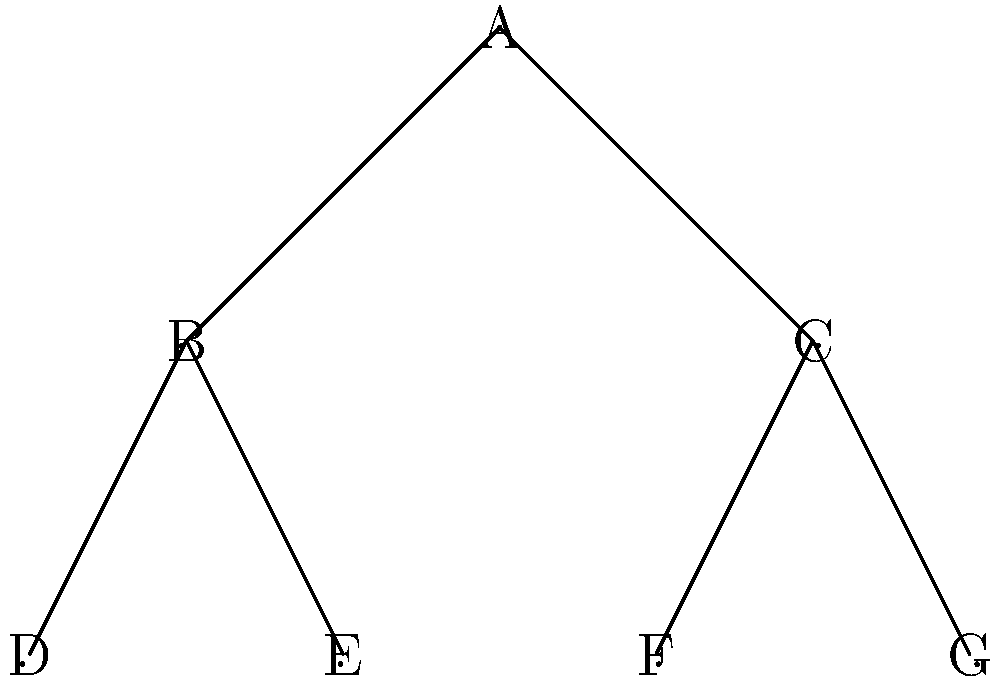In the hierarchical committee structure shown above, each node represents a subcommittee, and edges represent reporting relationships. What is the maximum number of subcommittees that can be eliminated while still maintaining a path from every remaining subcommittee to the top committee (A)? To solve this problem, we need to understand the concept of a minimum spanning tree in graph theory. Here's a step-by-step approach:

1. The given structure has 7 subcommittees (nodes) and 6 edges.

2. To maintain a path from every subcommittee to the top committee (A), we need to keep a connected tree structure.

3. The minimum number of edges required to connect n nodes in a tree is (n-1).

4. In this case, with 7 nodes, we need at least 6 edges to keep all nodes connected.

5. Therefore, the maximum number of edges we can remove is:
   Current number of edges - Minimum required edges = 6 - 6 = 0

6. Since we can't remove any edges without disconnecting the graph, we can't eliminate any subcommittees.

7. The maximum number of subcommittees that can be eliminated while maintaining connectivity is 0.

This solution ensures that all remaining subcommittees have a reporting path to the top committee, which is crucial for maintaining an efficient committee structure in a political organization.
Answer: 0 subcommittees 